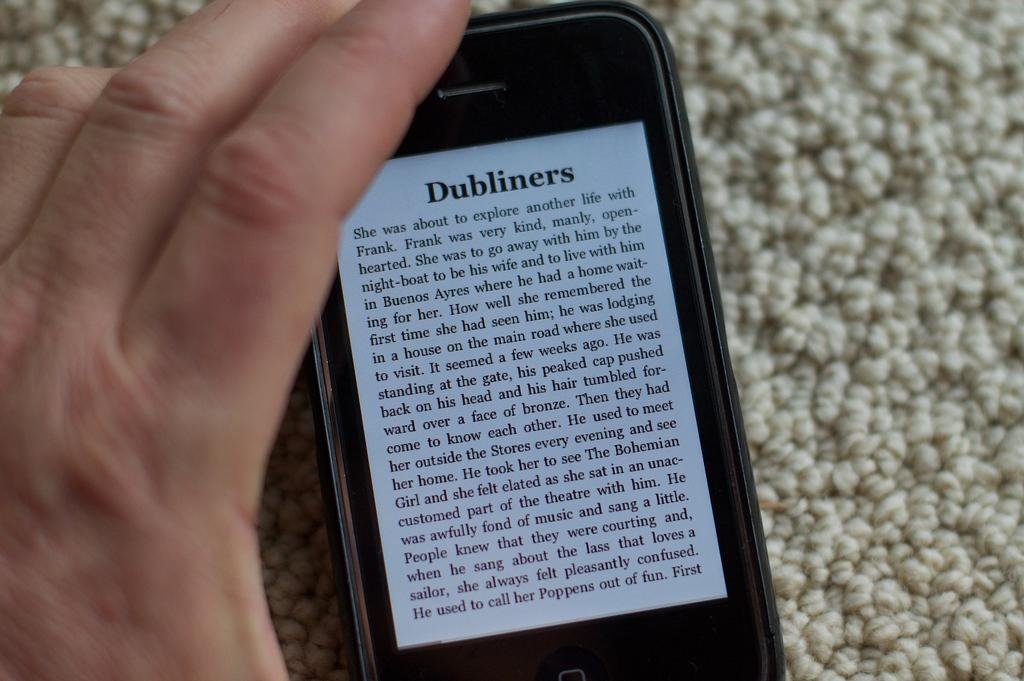<image>
Write a terse but informative summary of the picture. A small electronic device shows the text from a passage of Dubliners. 